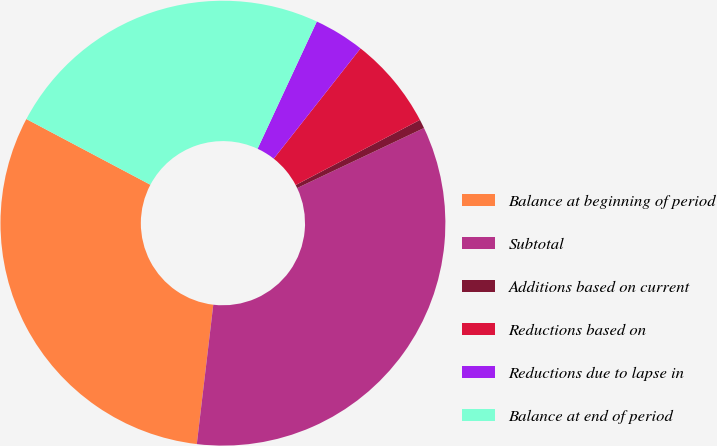<chart> <loc_0><loc_0><loc_500><loc_500><pie_chart><fcel>Balance at beginning of period<fcel>Subtotal<fcel>Additions based on current<fcel>Reductions based on<fcel>Reductions due to lapse in<fcel>Balance at end of period<nl><fcel>30.88%<fcel>33.91%<fcel>0.65%<fcel>6.7%<fcel>3.68%<fcel>24.18%<nl></chart> 